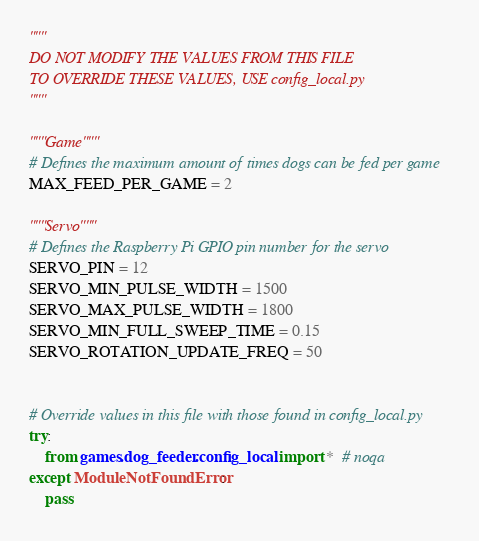Convert code to text. <code><loc_0><loc_0><loc_500><loc_500><_Python_>"""
DO NOT MODIFY THE VALUES FROM THIS FILE
TO OVERRIDE THESE VALUES, USE config_local.py
"""

"""Game"""
# Defines the maximum amount of times dogs can be fed per game
MAX_FEED_PER_GAME = 2

"""Servo"""
# Defines the Raspberry Pi GPIO pin number for the servo
SERVO_PIN = 12
SERVO_MIN_PULSE_WIDTH = 1500
SERVO_MAX_PULSE_WIDTH = 1800
SERVO_MIN_FULL_SWEEP_TIME = 0.15
SERVO_ROTATION_UPDATE_FREQ = 50


# Override values in this file with those found in config_local.py
try:
    from games.dog_feeder.config_local import *  # noqa
except ModuleNotFoundError:
    pass
</code> 